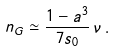Convert formula to latex. <formula><loc_0><loc_0><loc_500><loc_500>n _ { G } \simeq \frac { 1 - a ^ { 3 } } { 7 s _ { 0 } } \, \nu \, .</formula> 